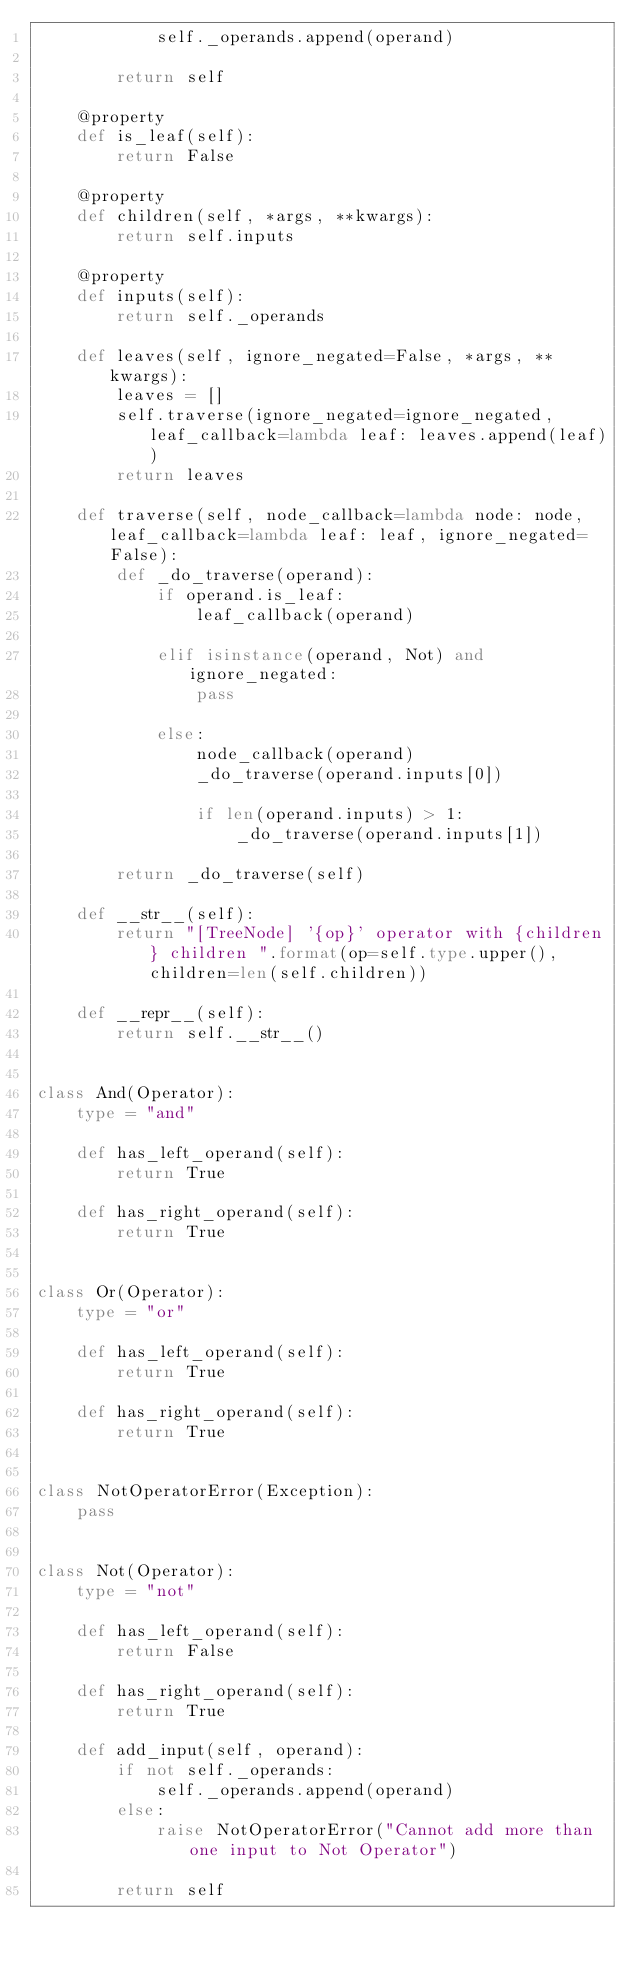<code> <loc_0><loc_0><loc_500><loc_500><_Python_>            self._operands.append(operand)

        return self

    @property
    def is_leaf(self):
        return False

    @property
    def children(self, *args, **kwargs):
        return self.inputs

    @property
    def inputs(self):
        return self._operands

    def leaves(self, ignore_negated=False, *args, **kwargs):
        leaves = []
        self.traverse(ignore_negated=ignore_negated, leaf_callback=lambda leaf: leaves.append(leaf))
        return leaves

    def traverse(self, node_callback=lambda node: node, leaf_callback=lambda leaf: leaf, ignore_negated=False):
        def _do_traverse(operand):
            if operand.is_leaf:
                leaf_callback(operand)

            elif isinstance(operand, Not) and ignore_negated:
                pass

            else:
                node_callback(operand)
                _do_traverse(operand.inputs[0])

                if len(operand.inputs) > 1:
                    _do_traverse(operand.inputs[1])

        return _do_traverse(self)

    def __str__(self):
        return "[TreeNode] '{op}' operator with {children} children ".format(op=self.type.upper(), children=len(self.children))

    def __repr__(self):
        return self.__str__()


class And(Operator):
    type = "and"

    def has_left_operand(self):
        return True

    def has_right_operand(self):
        return True


class Or(Operator):
    type = "or"

    def has_left_operand(self):
        return True

    def has_right_operand(self):
        return True


class NotOperatorError(Exception):
    pass


class Not(Operator):
    type = "not"

    def has_left_operand(self):
        return False

    def has_right_operand(self):
        return True

    def add_input(self, operand):
        if not self._operands:
            self._operands.append(operand)
        else:
            raise NotOperatorError("Cannot add more than one input to Not Operator")

        return self
</code> 